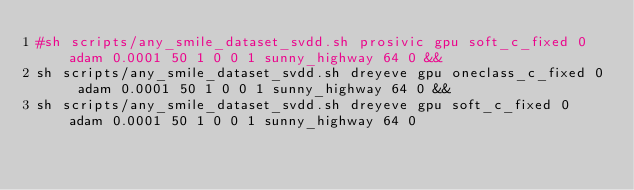Convert code to text. <code><loc_0><loc_0><loc_500><loc_500><_Bash_>#sh scripts/any_smile_dataset_svdd.sh prosivic gpu soft_c_fixed 0 adam 0.0001 50 1 0 0 1 sunny_highway 64 0 &&
sh scripts/any_smile_dataset_svdd.sh dreyeve gpu oneclass_c_fixed 0 adam 0.0001 50 1 0 0 1 sunny_highway 64 0 &&
sh scripts/any_smile_dataset_svdd.sh dreyeve gpu soft_c_fixed 0 adam 0.0001 50 1 0 0 1 sunny_highway 64 0

</code> 